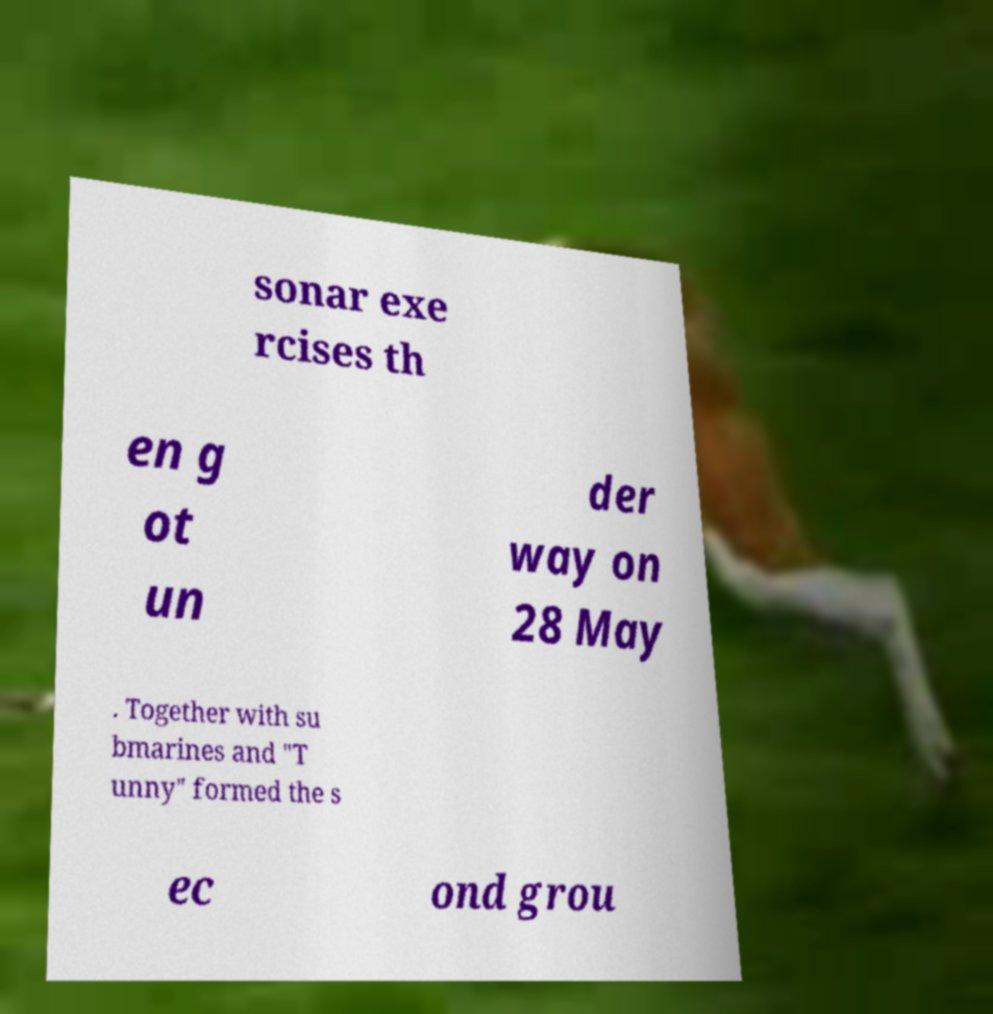I need the written content from this picture converted into text. Can you do that? sonar exe rcises th en g ot un der way on 28 May . Together with su bmarines and "T unny" formed the s ec ond grou 